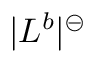Convert formula to latex. <formula><loc_0><loc_0><loc_500><loc_500>| L ^ { b } | ^ { \circleddash }</formula> 